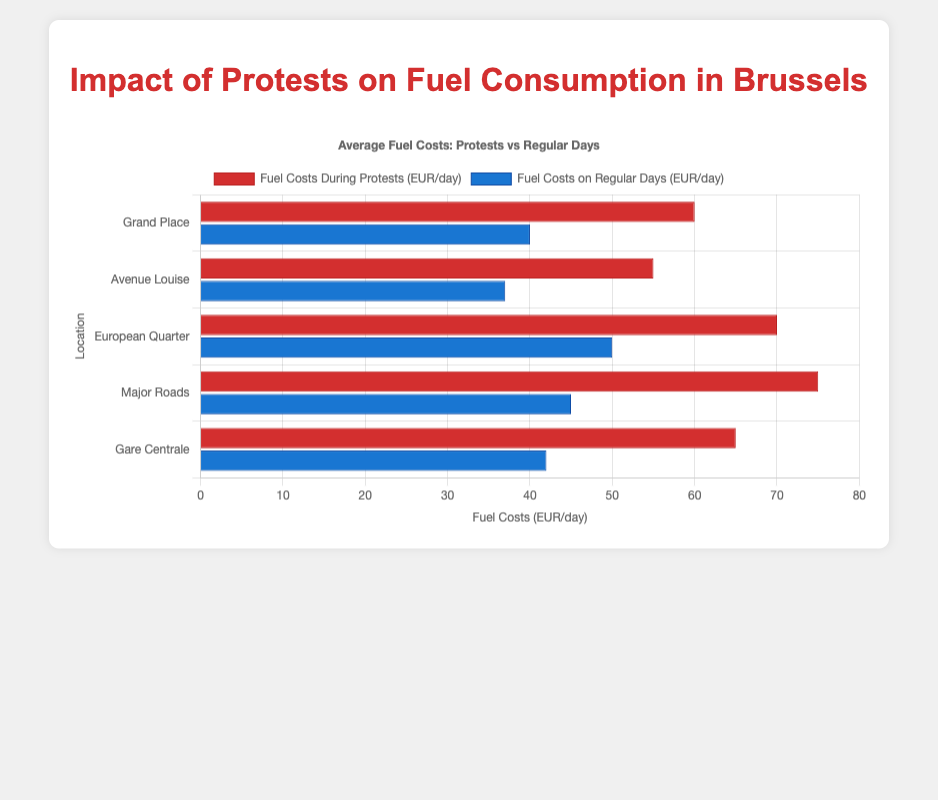Which location has the highest fuel cost during protests? The bars representing fuel costs during protests show that the 'Protest Blocking Major Roads' location has the highest value (75 EUR/day).
Answer: Major Roads What is the difference in fuel costs between protests and regular days for the Grand Place location? The fuel cost during protests for Grand Place is 60 EUR/day, and on regular days it's 40 EUR/day. The difference is 60 - 40 = 20 EUR/day.
Answer: 20 EUR/day Which location has the smallest increase in fuel costs from regular days to protest days? Compare the increases for all locations: Grand Place (60 - 40 = 20), Avenue Louise (55 - 37 = 18), European Quarter (70 - 50 = 20), Major Roads (75 - 45 = 30), Gare Centrale (65 - 42 = 23). The smallest increase is for Avenue Louise (18 EUR/day).
Answer: Avenue Louise Are the fuel costs always higher during protests in comparison to regular days for all locations? By comparing each location's bar heights for protests versus regular days: Grand Place (60 vs 40), Avenue Louise (55 vs 37), European Quarter (70 vs 50), Major Roads (75 vs 45), Gare Centrale (65 vs 42), we can see that protests always have higher fuel costs.
Answer: Yes What is the average fuel cost during protests across all locations? Sum the fuel costs during protests (60 + 55 + 70 + 75 + 65 = 325) and divide by the number of locations (5). The average is 325 / 5 = 65 EUR/day.
Answer: 65 EUR/day Which location has the lowest fuel cost on regular days? The bars representing fuel costs on regular days show that the 'Avenue Louise Route' has the lowest value (37 EUR/day).
Answer: Avenue Louise How much more expensive is fuel consumption during protests at the European Quarter compared to Avenue Louise? The fuel cost during protests at the European Quarter is 70 EUR/day, and at Avenue Louise, it’s 55 EUR/day. The difference is 70 - 55 = 15 EUR/day.
Answer: 15 EUR/day By how much do fuel costs increase on major roads due to protests? The fuel cost on regular days for Major Roads is 45 EUR/day, and during protests, it's 75 EUR/day. The increase is 75 - 45 = 30 EUR/day.
Answer: 30 EUR/day What is the combined fuel cost for Gare Centrale during protests and regular days? Sum the fuel costs for Gare Centrale during protests (65 EUR/day) and regular days (42 EUR/day). The combined cost is 65 + 42 = 107 EUR/day.
Answer: 107 EUR/day 